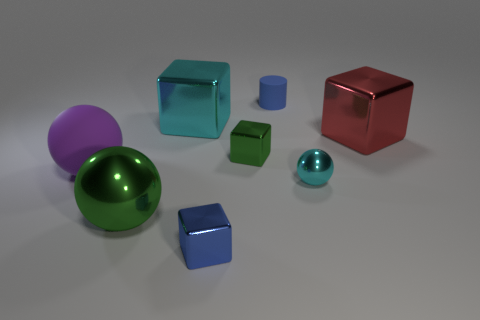Subtract all rubber spheres. How many spheres are left? 2 Add 2 green metallic spheres. How many objects exist? 10 Subtract all green cubes. How many cubes are left? 3 Subtract 4 blocks. How many blocks are left? 0 Add 4 blue metal things. How many blue metal things are left? 5 Add 6 yellow metallic cubes. How many yellow metallic cubes exist? 6 Subtract 1 blue cubes. How many objects are left? 7 Subtract all cylinders. How many objects are left? 7 Subtract all brown balls. Subtract all cyan blocks. How many balls are left? 3 Subtract all brown balls. How many red blocks are left? 1 